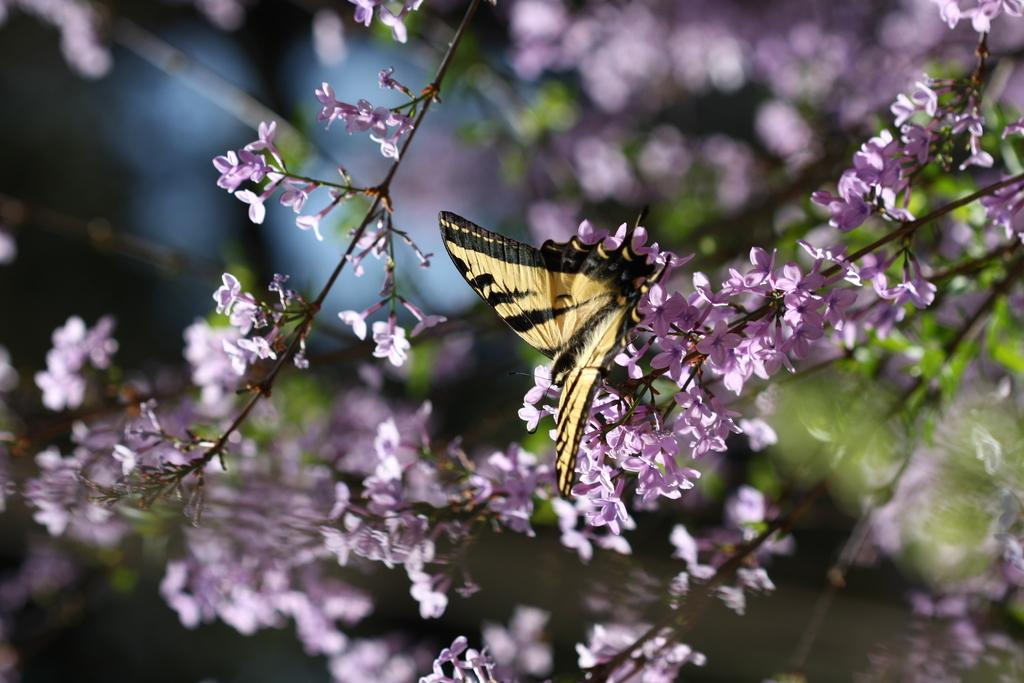What type of plants can be seen in the picture? There are flowering plants in the picture. What part of the flowering plants is visible? The stem of the flowering plants is visible. Are there any animals present in the picture? Yes, there is a butterfly in the picture. How many fingers can be seen on the flowering plants in the picture? There are no fingers present on the flowering plants in the picture, as they are plants and not human beings. 